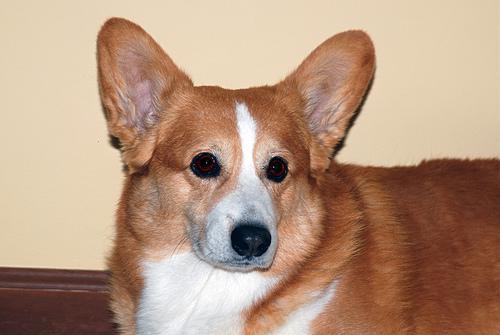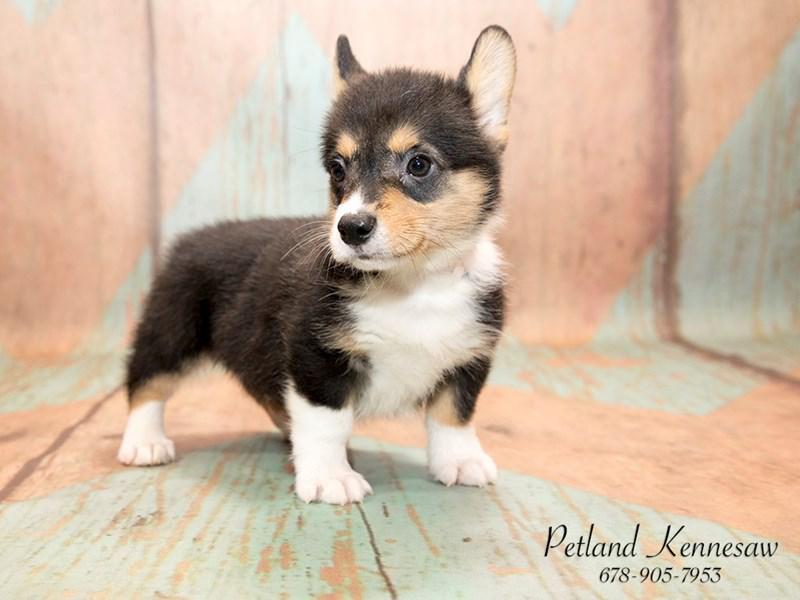The first image is the image on the left, the second image is the image on the right. Considering the images on both sides, is "One dog has its tongue out." valid? Answer yes or no. No. The first image is the image on the left, the second image is the image on the right. For the images displayed, is the sentence "One image contains a tri-color dog that is not reclining and has its body angled to the right." factually correct? Answer yes or no. Yes. 